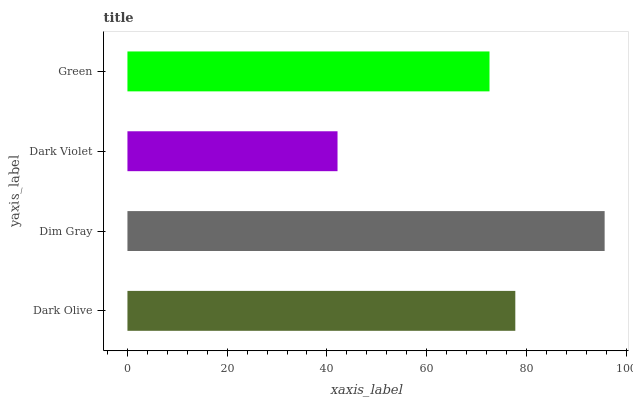Is Dark Violet the minimum?
Answer yes or no. Yes. Is Dim Gray the maximum?
Answer yes or no. Yes. Is Dim Gray the minimum?
Answer yes or no. No. Is Dark Violet the maximum?
Answer yes or no. No. Is Dim Gray greater than Dark Violet?
Answer yes or no. Yes. Is Dark Violet less than Dim Gray?
Answer yes or no. Yes. Is Dark Violet greater than Dim Gray?
Answer yes or no. No. Is Dim Gray less than Dark Violet?
Answer yes or no. No. Is Dark Olive the high median?
Answer yes or no. Yes. Is Green the low median?
Answer yes or no. Yes. Is Dim Gray the high median?
Answer yes or no. No. Is Dark Olive the low median?
Answer yes or no. No. 